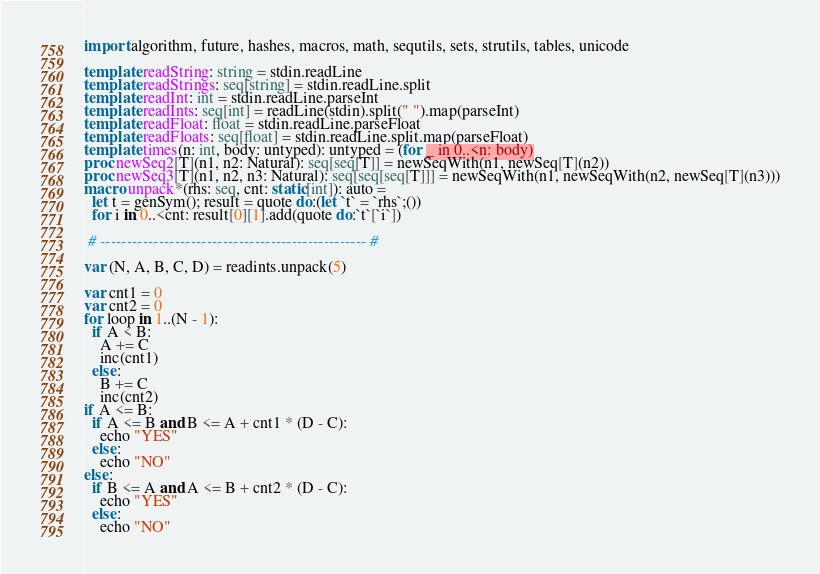Convert code to text. <code><loc_0><loc_0><loc_500><loc_500><_Nim_>import algorithm, future, hashes, macros, math, sequtils, sets, strutils, tables, unicode

template readString: string = stdin.readLine
template readStrings: seq[string] = stdin.readLine.split
template readInt: int = stdin.readLine.parseInt
template readInts: seq[int] = readLine(stdin).split(" ").map(parseInt)
template readFloat: float = stdin.readLine.parseFloat
template readFloats: seq[float] = stdin.readLine.split.map(parseFloat)
template times(n: int, body: untyped): untyped = (for _ in 0..<n: body)
proc newSeq2[T](n1, n2: Natural): seq[seq[T]] = newSeqWith(n1, newSeq[T](n2))
proc newSeq3[T](n1, n2, n3: Natural): seq[seq[seq[T]]] = newSeqWith(n1, newSeqWith(n2, newSeq[T](n3)))
macro unpack*(rhs: seq, cnt: static[int]): auto =
  let t = genSym(); result = quote do:(let `t` = `rhs`;())
  for i in 0..<cnt: result[0][1].add(quote do:`t`[`i`])

 # -------------------------------------------------- #

var (N, A, B, C, D) = readints.unpack(5)

var cnt1 = 0
var cnt2 = 0
for loop in 1..(N - 1):
  if A < B:
    A += C
    inc(cnt1)
  else:
    B += C
    inc(cnt2)
if A <= B:
  if A <= B and B <= A + cnt1 * (D - C):
    echo "YES"
  else:
    echo "NO"
else:
  if B <= A and A <= B + cnt2 * (D - C):
    echo "YES"
  else:
    echo "NO"</code> 